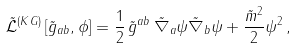Convert formula to latex. <formula><loc_0><loc_0><loc_500><loc_500>\tilde { \mathcal { L } } ^ { ( K G ) } \left [ \tilde { g } _ { a b } , \phi \right ] = \frac { 1 } { 2 } \, \tilde { g } ^ { a b } \, \tilde { \nabla } _ { a } \psi \tilde { \nabla } _ { b } \psi + \frac { \tilde { m } ^ { 2 } } { 2 } \psi ^ { 2 } \, ,</formula> 